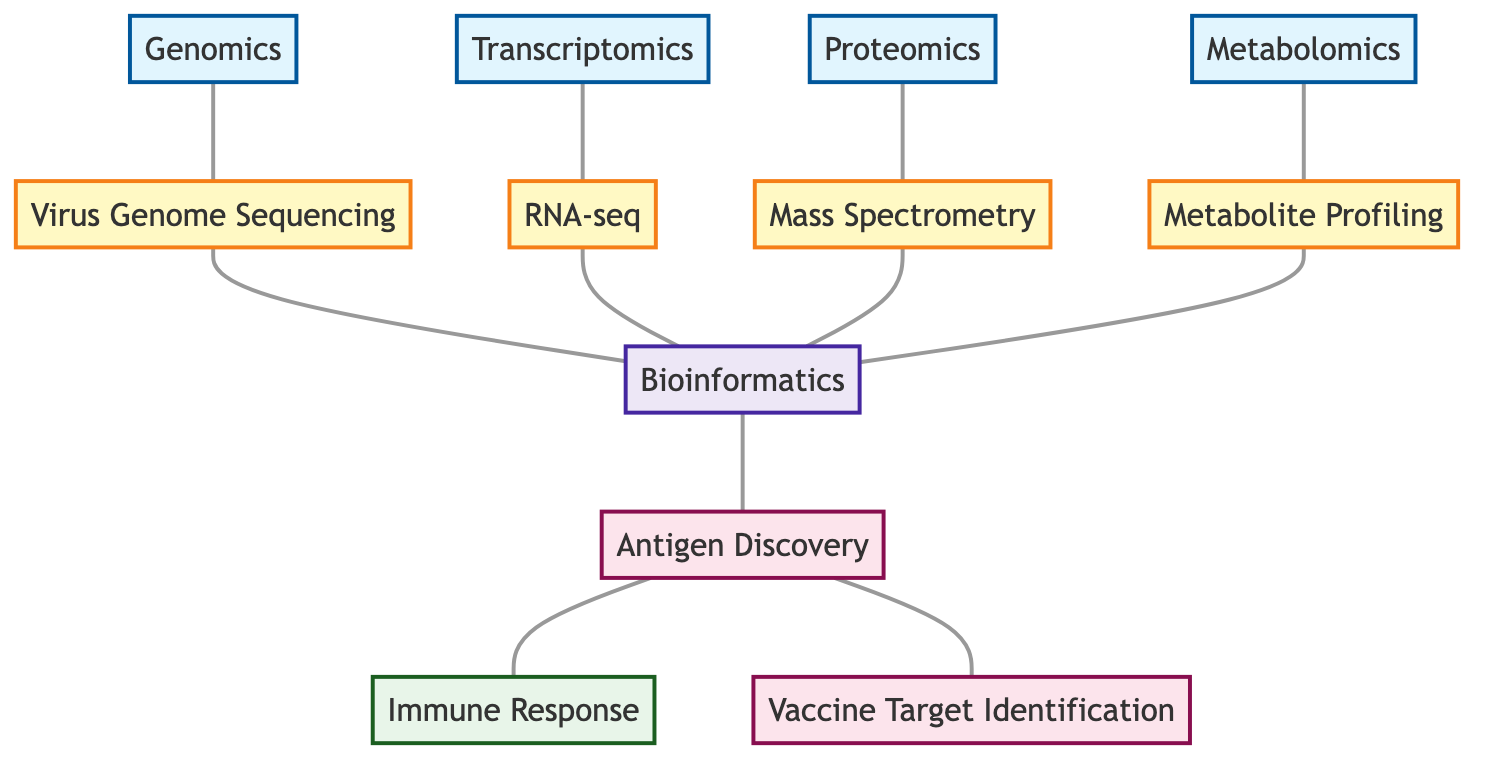What are the four types of data represented in the diagram? The diagram shows four types of data nodes: Genomics, Transcriptomics, Proteomics, and Metabolomics.
Answer: Genomics, Transcriptomics, Proteomics, Metabolomics How many techniques are illustrated in the diagram? There are four techniques represented in the diagram: Virus Genome Sequencing, RNA-seq, Mass Spectrometry, and Metabolite Profiling.
Answer: 4 Which technique is connected to Genomics? The technique connected to Genomics is Virus Genome Sequencing.
Answer: Virus Genome Sequencing What is the relationship between Antigen Discovery and Immune Response? Antigen Discovery is directly connected to Immune Response, indicating a causal or related relationship.
Answer: Direct connection Which methodology connects all data techniques to antigen discovery? The methodology that connects all data techniques to antigen discovery is Bioinformatics.
Answer: Bioinformatics How many edges are connected to the Bioinformatics node? The Bioinformatics node is connected to four edges: one from Virus Genome Sequencing, one from RNA-seq, one from Mass Spectrometry, and one from Metabolite Profiling.
Answer: 4 What is the final goal related to Antigen Discovery? The final goal related to Antigen Discovery is Vaccine Target Identification.
Answer: Vaccine Target Identification What type of data do Mass Spectrometry and Metabolite Profiling nodes represent? Both Mass Spectrometry and Metabolite Profiling represent the type of data known as Proteomics and Metabolomics respectively.
Answer: Technique Which node has the most connections? The node with the most connections is the Bioinformatics node, as it connects to all four techniques and then leads to both goals of Antigen Discovery and Vaccine Target Identification.
Answer: Bioinformatics 